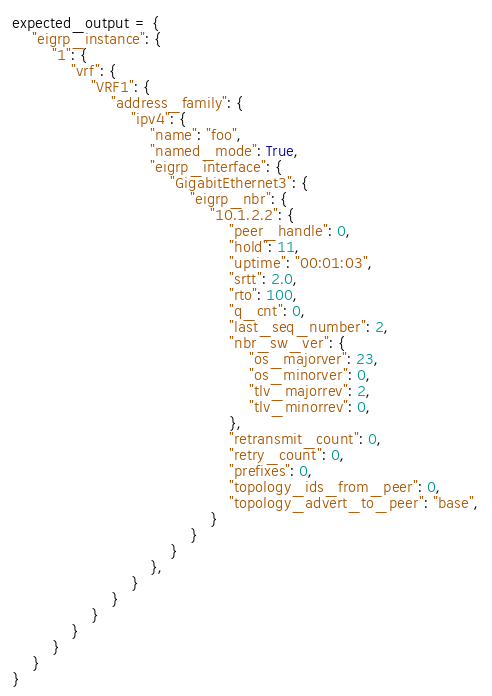Convert code to text. <code><loc_0><loc_0><loc_500><loc_500><_Python_>expected_output = {
    "eigrp_instance": {
        "1": {
            "vrf": {
                "VRF1": {
                    "address_family": {
                        "ipv4": {
                            "name": "foo",
                            "named_mode": True,
                            "eigrp_interface": {
                                "GigabitEthernet3": {
                                    "eigrp_nbr": {
                                        "10.1.2.2": {
                                            "peer_handle": 0,
                                            "hold": 11,
                                            "uptime": "00:01:03",
                                            "srtt": 2.0,
                                            "rto": 100,
                                            "q_cnt": 0,
                                            "last_seq_number": 2,
                                            "nbr_sw_ver": {
                                                "os_majorver": 23,
                                                "os_minorver": 0,
                                                "tlv_majorrev": 2,
                                                "tlv_minorrev": 0,
                                            },
                                            "retransmit_count": 0,
                                            "retry_count": 0,
                                            "prefixes": 0,
                                            "topology_ids_from_peer": 0,
                                            "topology_advert_to_peer": "base",
                                        }
                                    }
                                }
                            },
                        }
                    }
                }
            }
        }
    }
}
</code> 